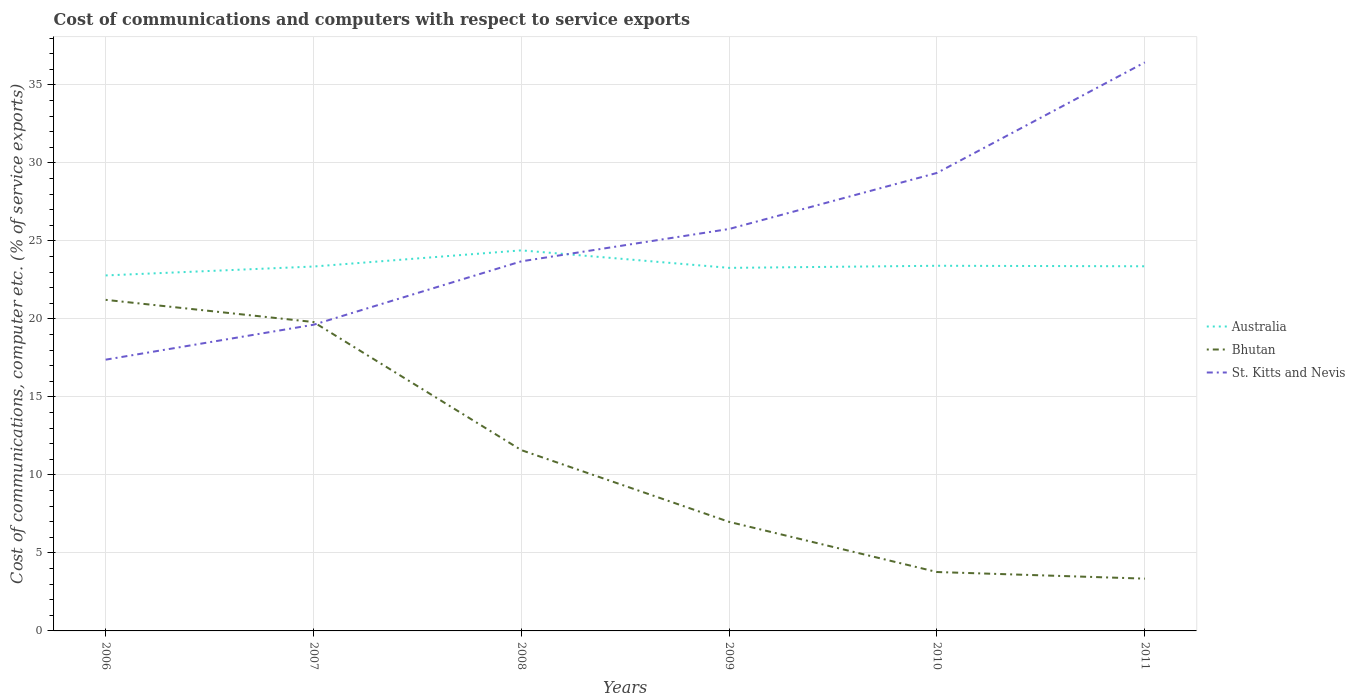Is the number of lines equal to the number of legend labels?
Your answer should be compact. Yes. Across all years, what is the maximum cost of communications and computers in Australia?
Your response must be concise. 22.79. What is the total cost of communications and computers in Australia in the graph?
Keep it short and to the point. -0.13. What is the difference between the highest and the second highest cost of communications and computers in St. Kitts and Nevis?
Offer a terse response. 19.05. How many lines are there?
Offer a very short reply. 3. What is the difference between two consecutive major ticks on the Y-axis?
Ensure brevity in your answer.  5. Does the graph contain any zero values?
Your answer should be compact. No. Does the graph contain grids?
Offer a very short reply. Yes. How many legend labels are there?
Provide a succinct answer. 3. How are the legend labels stacked?
Keep it short and to the point. Vertical. What is the title of the graph?
Provide a succinct answer. Cost of communications and computers with respect to service exports. Does "Least developed countries" appear as one of the legend labels in the graph?
Offer a very short reply. No. What is the label or title of the X-axis?
Provide a short and direct response. Years. What is the label or title of the Y-axis?
Keep it short and to the point. Cost of communications, computer etc. (% of service exports). What is the Cost of communications, computer etc. (% of service exports) of Australia in 2006?
Make the answer very short. 22.79. What is the Cost of communications, computer etc. (% of service exports) in Bhutan in 2006?
Ensure brevity in your answer.  21.22. What is the Cost of communications, computer etc. (% of service exports) in St. Kitts and Nevis in 2006?
Give a very brief answer. 17.39. What is the Cost of communications, computer etc. (% of service exports) of Australia in 2007?
Provide a succinct answer. 23.36. What is the Cost of communications, computer etc. (% of service exports) of Bhutan in 2007?
Your answer should be compact. 19.8. What is the Cost of communications, computer etc. (% of service exports) in St. Kitts and Nevis in 2007?
Your answer should be compact. 19.62. What is the Cost of communications, computer etc. (% of service exports) of Australia in 2008?
Keep it short and to the point. 24.39. What is the Cost of communications, computer etc. (% of service exports) of Bhutan in 2008?
Give a very brief answer. 11.59. What is the Cost of communications, computer etc. (% of service exports) in St. Kitts and Nevis in 2008?
Your answer should be very brief. 23.69. What is the Cost of communications, computer etc. (% of service exports) of Australia in 2009?
Ensure brevity in your answer.  23.27. What is the Cost of communications, computer etc. (% of service exports) in Bhutan in 2009?
Your answer should be compact. 6.99. What is the Cost of communications, computer etc. (% of service exports) in St. Kitts and Nevis in 2009?
Your answer should be very brief. 25.76. What is the Cost of communications, computer etc. (% of service exports) of Australia in 2010?
Keep it short and to the point. 23.41. What is the Cost of communications, computer etc. (% of service exports) of Bhutan in 2010?
Your answer should be very brief. 3.78. What is the Cost of communications, computer etc. (% of service exports) of St. Kitts and Nevis in 2010?
Offer a terse response. 29.36. What is the Cost of communications, computer etc. (% of service exports) of Australia in 2011?
Your response must be concise. 23.37. What is the Cost of communications, computer etc. (% of service exports) in Bhutan in 2011?
Offer a very short reply. 3.35. What is the Cost of communications, computer etc. (% of service exports) of St. Kitts and Nevis in 2011?
Give a very brief answer. 36.44. Across all years, what is the maximum Cost of communications, computer etc. (% of service exports) in Australia?
Ensure brevity in your answer.  24.39. Across all years, what is the maximum Cost of communications, computer etc. (% of service exports) in Bhutan?
Give a very brief answer. 21.22. Across all years, what is the maximum Cost of communications, computer etc. (% of service exports) in St. Kitts and Nevis?
Give a very brief answer. 36.44. Across all years, what is the minimum Cost of communications, computer etc. (% of service exports) in Australia?
Your answer should be very brief. 22.79. Across all years, what is the minimum Cost of communications, computer etc. (% of service exports) in Bhutan?
Keep it short and to the point. 3.35. Across all years, what is the minimum Cost of communications, computer etc. (% of service exports) in St. Kitts and Nevis?
Give a very brief answer. 17.39. What is the total Cost of communications, computer etc. (% of service exports) of Australia in the graph?
Your answer should be very brief. 140.58. What is the total Cost of communications, computer etc. (% of service exports) in Bhutan in the graph?
Your answer should be very brief. 66.72. What is the total Cost of communications, computer etc. (% of service exports) in St. Kitts and Nevis in the graph?
Keep it short and to the point. 152.26. What is the difference between the Cost of communications, computer etc. (% of service exports) in Australia in 2006 and that in 2007?
Keep it short and to the point. -0.57. What is the difference between the Cost of communications, computer etc. (% of service exports) of Bhutan in 2006 and that in 2007?
Your answer should be compact. 1.42. What is the difference between the Cost of communications, computer etc. (% of service exports) in St. Kitts and Nevis in 2006 and that in 2007?
Offer a terse response. -2.24. What is the difference between the Cost of communications, computer etc. (% of service exports) of Australia in 2006 and that in 2008?
Provide a short and direct response. -1.61. What is the difference between the Cost of communications, computer etc. (% of service exports) of Bhutan in 2006 and that in 2008?
Your answer should be very brief. 9.63. What is the difference between the Cost of communications, computer etc. (% of service exports) in St. Kitts and Nevis in 2006 and that in 2008?
Provide a short and direct response. -6.3. What is the difference between the Cost of communications, computer etc. (% of service exports) in Australia in 2006 and that in 2009?
Make the answer very short. -0.48. What is the difference between the Cost of communications, computer etc. (% of service exports) in Bhutan in 2006 and that in 2009?
Your answer should be very brief. 14.23. What is the difference between the Cost of communications, computer etc. (% of service exports) in St. Kitts and Nevis in 2006 and that in 2009?
Offer a terse response. -8.38. What is the difference between the Cost of communications, computer etc. (% of service exports) in Australia in 2006 and that in 2010?
Make the answer very short. -0.62. What is the difference between the Cost of communications, computer etc. (% of service exports) in Bhutan in 2006 and that in 2010?
Offer a very short reply. 17.45. What is the difference between the Cost of communications, computer etc. (% of service exports) in St. Kitts and Nevis in 2006 and that in 2010?
Make the answer very short. -11.97. What is the difference between the Cost of communications, computer etc. (% of service exports) in Australia in 2006 and that in 2011?
Provide a short and direct response. -0.59. What is the difference between the Cost of communications, computer etc. (% of service exports) in Bhutan in 2006 and that in 2011?
Offer a terse response. 17.87. What is the difference between the Cost of communications, computer etc. (% of service exports) of St. Kitts and Nevis in 2006 and that in 2011?
Offer a very short reply. -19.05. What is the difference between the Cost of communications, computer etc. (% of service exports) in Australia in 2007 and that in 2008?
Ensure brevity in your answer.  -1.04. What is the difference between the Cost of communications, computer etc. (% of service exports) of Bhutan in 2007 and that in 2008?
Ensure brevity in your answer.  8.21. What is the difference between the Cost of communications, computer etc. (% of service exports) in St. Kitts and Nevis in 2007 and that in 2008?
Give a very brief answer. -4.06. What is the difference between the Cost of communications, computer etc. (% of service exports) of Australia in 2007 and that in 2009?
Offer a very short reply. 0.09. What is the difference between the Cost of communications, computer etc. (% of service exports) in Bhutan in 2007 and that in 2009?
Your response must be concise. 12.81. What is the difference between the Cost of communications, computer etc. (% of service exports) in St. Kitts and Nevis in 2007 and that in 2009?
Keep it short and to the point. -6.14. What is the difference between the Cost of communications, computer etc. (% of service exports) in Australia in 2007 and that in 2010?
Your answer should be compact. -0.05. What is the difference between the Cost of communications, computer etc. (% of service exports) in Bhutan in 2007 and that in 2010?
Give a very brief answer. 16.02. What is the difference between the Cost of communications, computer etc. (% of service exports) of St. Kitts and Nevis in 2007 and that in 2010?
Offer a very short reply. -9.73. What is the difference between the Cost of communications, computer etc. (% of service exports) of Australia in 2007 and that in 2011?
Your answer should be very brief. -0.02. What is the difference between the Cost of communications, computer etc. (% of service exports) in Bhutan in 2007 and that in 2011?
Offer a very short reply. 16.45. What is the difference between the Cost of communications, computer etc. (% of service exports) of St. Kitts and Nevis in 2007 and that in 2011?
Your response must be concise. -16.82. What is the difference between the Cost of communications, computer etc. (% of service exports) of Australia in 2008 and that in 2009?
Make the answer very short. 1.12. What is the difference between the Cost of communications, computer etc. (% of service exports) of Bhutan in 2008 and that in 2009?
Your answer should be compact. 4.6. What is the difference between the Cost of communications, computer etc. (% of service exports) of St. Kitts and Nevis in 2008 and that in 2009?
Provide a short and direct response. -2.07. What is the difference between the Cost of communications, computer etc. (% of service exports) of Australia in 2008 and that in 2010?
Your answer should be very brief. 0.99. What is the difference between the Cost of communications, computer etc. (% of service exports) in Bhutan in 2008 and that in 2010?
Provide a short and direct response. 7.81. What is the difference between the Cost of communications, computer etc. (% of service exports) of St. Kitts and Nevis in 2008 and that in 2010?
Ensure brevity in your answer.  -5.67. What is the difference between the Cost of communications, computer etc. (% of service exports) of Australia in 2008 and that in 2011?
Offer a very short reply. 1.02. What is the difference between the Cost of communications, computer etc. (% of service exports) in Bhutan in 2008 and that in 2011?
Offer a terse response. 8.24. What is the difference between the Cost of communications, computer etc. (% of service exports) in St. Kitts and Nevis in 2008 and that in 2011?
Keep it short and to the point. -12.75. What is the difference between the Cost of communications, computer etc. (% of service exports) in Australia in 2009 and that in 2010?
Provide a short and direct response. -0.13. What is the difference between the Cost of communications, computer etc. (% of service exports) in Bhutan in 2009 and that in 2010?
Give a very brief answer. 3.21. What is the difference between the Cost of communications, computer etc. (% of service exports) of St. Kitts and Nevis in 2009 and that in 2010?
Your answer should be compact. -3.59. What is the difference between the Cost of communications, computer etc. (% of service exports) in Australia in 2009 and that in 2011?
Provide a short and direct response. -0.1. What is the difference between the Cost of communications, computer etc. (% of service exports) in Bhutan in 2009 and that in 2011?
Offer a very short reply. 3.64. What is the difference between the Cost of communications, computer etc. (% of service exports) in St. Kitts and Nevis in 2009 and that in 2011?
Offer a terse response. -10.68. What is the difference between the Cost of communications, computer etc. (% of service exports) in Australia in 2010 and that in 2011?
Your answer should be very brief. 0.03. What is the difference between the Cost of communications, computer etc. (% of service exports) in Bhutan in 2010 and that in 2011?
Your answer should be compact. 0.42. What is the difference between the Cost of communications, computer etc. (% of service exports) in St. Kitts and Nevis in 2010 and that in 2011?
Your answer should be compact. -7.08. What is the difference between the Cost of communications, computer etc. (% of service exports) of Australia in 2006 and the Cost of communications, computer etc. (% of service exports) of Bhutan in 2007?
Your answer should be very brief. 2.99. What is the difference between the Cost of communications, computer etc. (% of service exports) in Australia in 2006 and the Cost of communications, computer etc. (% of service exports) in St. Kitts and Nevis in 2007?
Your response must be concise. 3.16. What is the difference between the Cost of communications, computer etc. (% of service exports) of Bhutan in 2006 and the Cost of communications, computer etc. (% of service exports) of St. Kitts and Nevis in 2007?
Make the answer very short. 1.6. What is the difference between the Cost of communications, computer etc. (% of service exports) of Australia in 2006 and the Cost of communications, computer etc. (% of service exports) of Bhutan in 2008?
Offer a terse response. 11.2. What is the difference between the Cost of communications, computer etc. (% of service exports) in Australia in 2006 and the Cost of communications, computer etc. (% of service exports) in St. Kitts and Nevis in 2008?
Provide a succinct answer. -0.9. What is the difference between the Cost of communications, computer etc. (% of service exports) in Bhutan in 2006 and the Cost of communications, computer etc. (% of service exports) in St. Kitts and Nevis in 2008?
Make the answer very short. -2.47. What is the difference between the Cost of communications, computer etc. (% of service exports) in Australia in 2006 and the Cost of communications, computer etc. (% of service exports) in Bhutan in 2009?
Provide a succinct answer. 15.8. What is the difference between the Cost of communications, computer etc. (% of service exports) of Australia in 2006 and the Cost of communications, computer etc. (% of service exports) of St. Kitts and Nevis in 2009?
Your answer should be compact. -2.98. What is the difference between the Cost of communications, computer etc. (% of service exports) in Bhutan in 2006 and the Cost of communications, computer etc. (% of service exports) in St. Kitts and Nevis in 2009?
Provide a short and direct response. -4.54. What is the difference between the Cost of communications, computer etc. (% of service exports) of Australia in 2006 and the Cost of communications, computer etc. (% of service exports) of Bhutan in 2010?
Keep it short and to the point. 19.01. What is the difference between the Cost of communications, computer etc. (% of service exports) in Australia in 2006 and the Cost of communications, computer etc. (% of service exports) in St. Kitts and Nevis in 2010?
Offer a very short reply. -6.57. What is the difference between the Cost of communications, computer etc. (% of service exports) of Bhutan in 2006 and the Cost of communications, computer etc. (% of service exports) of St. Kitts and Nevis in 2010?
Keep it short and to the point. -8.14. What is the difference between the Cost of communications, computer etc. (% of service exports) of Australia in 2006 and the Cost of communications, computer etc. (% of service exports) of Bhutan in 2011?
Keep it short and to the point. 19.43. What is the difference between the Cost of communications, computer etc. (% of service exports) in Australia in 2006 and the Cost of communications, computer etc. (% of service exports) in St. Kitts and Nevis in 2011?
Ensure brevity in your answer.  -13.66. What is the difference between the Cost of communications, computer etc. (% of service exports) in Bhutan in 2006 and the Cost of communications, computer etc. (% of service exports) in St. Kitts and Nevis in 2011?
Your answer should be compact. -15.22. What is the difference between the Cost of communications, computer etc. (% of service exports) in Australia in 2007 and the Cost of communications, computer etc. (% of service exports) in Bhutan in 2008?
Ensure brevity in your answer.  11.77. What is the difference between the Cost of communications, computer etc. (% of service exports) of Australia in 2007 and the Cost of communications, computer etc. (% of service exports) of St. Kitts and Nevis in 2008?
Offer a very short reply. -0.33. What is the difference between the Cost of communications, computer etc. (% of service exports) of Bhutan in 2007 and the Cost of communications, computer etc. (% of service exports) of St. Kitts and Nevis in 2008?
Give a very brief answer. -3.89. What is the difference between the Cost of communications, computer etc. (% of service exports) of Australia in 2007 and the Cost of communications, computer etc. (% of service exports) of Bhutan in 2009?
Make the answer very short. 16.37. What is the difference between the Cost of communications, computer etc. (% of service exports) in Australia in 2007 and the Cost of communications, computer etc. (% of service exports) in St. Kitts and Nevis in 2009?
Offer a terse response. -2.41. What is the difference between the Cost of communications, computer etc. (% of service exports) of Bhutan in 2007 and the Cost of communications, computer etc. (% of service exports) of St. Kitts and Nevis in 2009?
Your answer should be compact. -5.96. What is the difference between the Cost of communications, computer etc. (% of service exports) of Australia in 2007 and the Cost of communications, computer etc. (% of service exports) of Bhutan in 2010?
Offer a very short reply. 19.58. What is the difference between the Cost of communications, computer etc. (% of service exports) of Australia in 2007 and the Cost of communications, computer etc. (% of service exports) of St. Kitts and Nevis in 2010?
Keep it short and to the point. -6. What is the difference between the Cost of communications, computer etc. (% of service exports) in Bhutan in 2007 and the Cost of communications, computer etc. (% of service exports) in St. Kitts and Nevis in 2010?
Your answer should be compact. -9.56. What is the difference between the Cost of communications, computer etc. (% of service exports) of Australia in 2007 and the Cost of communications, computer etc. (% of service exports) of Bhutan in 2011?
Make the answer very short. 20.01. What is the difference between the Cost of communications, computer etc. (% of service exports) in Australia in 2007 and the Cost of communications, computer etc. (% of service exports) in St. Kitts and Nevis in 2011?
Offer a very short reply. -13.08. What is the difference between the Cost of communications, computer etc. (% of service exports) in Bhutan in 2007 and the Cost of communications, computer etc. (% of service exports) in St. Kitts and Nevis in 2011?
Offer a very short reply. -16.64. What is the difference between the Cost of communications, computer etc. (% of service exports) of Australia in 2008 and the Cost of communications, computer etc. (% of service exports) of Bhutan in 2009?
Make the answer very short. 17.4. What is the difference between the Cost of communications, computer etc. (% of service exports) of Australia in 2008 and the Cost of communications, computer etc. (% of service exports) of St. Kitts and Nevis in 2009?
Offer a terse response. -1.37. What is the difference between the Cost of communications, computer etc. (% of service exports) in Bhutan in 2008 and the Cost of communications, computer etc. (% of service exports) in St. Kitts and Nevis in 2009?
Offer a very short reply. -14.17. What is the difference between the Cost of communications, computer etc. (% of service exports) in Australia in 2008 and the Cost of communications, computer etc. (% of service exports) in Bhutan in 2010?
Provide a succinct answer. 20.62. What is the difference between the Cost of communications, computer etc. (% of service exports) of Australia in 2008 and the Cost of communications, computer etc. (% of service exports) of St. Kitts and Nevis in 2010?
Offer a terse response. -4.96. What is the difference between the Cost of communications, computer etc. (% of service exports) in Bhutan in 2008 and the Cost of communications, computer etc. (% of service exports) in St. Kitts and Nevis in 2010?
Ensure brevity in your answer.  -17.77. What is the difference between the Cost of communications, computer etc. (% of service exports) of Australia in 2008 and the Cost of communications, computer etc. (% of service exports) of Bhutan in 2011?
Offer a terse response. 21.04. What is the difference between the Cost of communications, computer etc. (% of service exports) in Australia in 2008 and the Cost of communications, computer etc. (% of service exports) in St. Kitts and Nevis in 2011?
Give a very brief answer. -12.05. What is the difference between the Cost of communications, computer etc. (% of service exports) of Bhutan in 2008 and the Cost of communications, computer etc. (% of service exports) of St. Kitts and Nevis in 2011?
Provide a succinct answer. -24.85. What is the difference between the Cost of communications, computer etc. (% of service exports) in Australia in 2009 and the Cost of communications, computer etc. (% of service exports) in Bhutan in 2010?
Offer a very short reply. 19.5. What is the difference between the Cost of communications, computer etc. (% of service exports) of Australia in 2009 and the Cost of communications, computer etc. (% of service exports) of St. Kitts and Nevis in 2010?
Your answer should be very brief. -6.09. What is the difference between the Cost of communications, computer etc. (% of service exports) in Bhutan in 2009 and the Cost of communications, computer etc. (% of service exports) in St. Kitts and Nevis in 2010?
Make the answer very short. -22.37. What is the difference between the Cost of communications, computer etc. (% of service exports) in Australia in 2009 and the Cost of communications, computer etc. (% of service exports) in Bhutan in 2011?
Provide a short and direct response. 19.92. What is the difference between the Cost of communications, computer etc. (% of service exports) of Australia in 2009 and the Cost of communications, computer etc. (% of service exports) of St. Kitts and Nevis in 2011?
Provide a short and direct response. -13.17. What is the difference between the Cost of communications, computer etc. (% of service exports) in Bhutan in 2009 and the Cost of communications, computer etc. (% of service exports) in St. Kitts and Nevis in 2011?
Give a very brief answer. -29.45. What is the difference between the Cost of communications, computer etc. (% of service exports) of Australia in 2010 and the Cost of communications, computer etc. (% of service exports) of Bhutan in 2011?
Give a very brief answer. 20.05. What is the difference between the Cost of communications, computer etc. (% of service exports) of Australia in 2010 and the Cost of communications, computer etc. (% of service exports) of St. Kitts and Nevis in 2011?
Your answer should be very brief. -13.04. What is the difference between the Cost of communications, computer etc. (% of service exports) of Bhutan in 2010 and the Cost of communications, computer etc. (% of service exports) of St. Kitts and Nevis in 2011?
Your answer should be very brief. -32.67. What is the average Cost of communications, computer etc. (% of service exports) in Australia per year?
Offer a terse response. 23.43. What is the average Cost of communications, computer etc. (% of service exports) in Bhutan per year?
Your answer should be compact. 11.12. What is the average Cost of communications, computer etc. (% of service exports) of St. Kitts and Nevis per year?
Your answer should be very brief. 25.38. In the year 2006, what is the difference between the Cost of communications, computer etc. (% of service exports) in Australia and Cost of communications, computer etc. (% of service exports) in Bhutan?
Your response must be concise. 1.56. In the year 2006, what is the difference between the Cost of communications, computer etc. (% of service exports) of Australia and Cost of communications, computer etc. (% of service exports) of St. Kitts and Nevis?
Your answer should be compact. 5.4. In the year 2006, what is the difference between the Cost of communications, computer etc. (% of service exports) of Bhutan and Cost of communications, computer etc. (% of service exports) of St. Kitts and Nevis?
Provide a succinct answer. 3.83. In the year 2007, what is the difference between the Cost of communications, computer etc. (% of service exports) of Australia and Cost of communications, computer etc. (% of service exports) of Bhutan?
Your answer should be very brief. 3.56. In the year 2007, what is the difference between the Cost of communications, computer etc. (% of service exports) of Australia and Cost of communications, computer etc. (% of service exports) of St. Kitts and Nevis?
Your answer should be compact. 3.73. In the year 2007, what is the difference between the Cost of communications, computer etc. (% of service exports) of Bhutan and Cost of communications, computer etc. (% of service exports) of St. Kitts and Nevis?
Provide a succinct answer. 0.17. In the year 2008, what is the difference between the Cost of communications, computer etc. (% of service exports) in Australia and Cost of communications, computer etc. (% of service exports) in Bhutan?
Offer a very short reply. 12.8. In the year 2008, what is the difference between the Cost of communications, computer etc. (% of service exports) of Australia and Cost of communications, computer etc. (% of service exports) of St. Kitts and Nevis?
Keep it short and to the point. 0.7. In the year 2008, what is the difference between the Cost of communications, computer etc. (% of service exports) in Bhutan and Cost of communications, computer etc. (% of service exports) in St. Kitts and Nevis?
Your response must be concise. -12.1. In the year 2009, what is the difference between the Cost of communications, computer etc. (% of service exports) in Australia and Cost of communications, computer etc. (% of service exports) in Bhutan?
Ensure brevity in your answer.  16.28. In the year 2009, what is the difference between the Cost of communications, computer etc. (% of service exports) in Australia and Cost of communications, computer etc. (% of service exports) in St. Kitts and Nevis?
Your response must be concise. -2.49. In the year 2009, what is the difference between the Cost of communications, computer etc. (% of service exports) in Bhutan and Cost of communications, computer etc. (% of service exports) in St. Kitts and Nevis?
Offer a terse response. -18.77. In the year 2010, what is the difference between the Cost of communications, computer etc. (% of service exports) in Australia and Cost of communications, computer etc. (% of service exports) in Bhutan?
Ensure brevity in your answer.  19.63. In the year 2010, what is the difference between the Cost of communications, computer etc. (% of service exports) of Australia and Cost of communications, computer etc. (% of service exports) of St. Kitts and Nevis?
Ensure brevity in your answer.  -5.95. In the year 2010, what is the difference between the Cost of communications, computer etc. (% of service exports) in Bhutan and Cost of communications, computer etc. (% of service exports) in St. Kitts and Nevis?
Your answer should be very brief. -25.58. In the year 2011, what is the difference between the Cost of communications, computer etc. (% of service exports) of Australia and Cost of communications, computer etc. (% of service exports) of Bhutan?
Give a very brief answer. 20.02. In the year 2011, what is the difference between the Cost of communications, computer etc. (% of service exports) of Australia and Cost of communications, computer etc. (% of service exports) of St. Kitts and Nevis?
Give a very brief answer. -13.07. In the year 2011, what is the difference between the Cost of communications, computer etc. (% of service exports) of Bhutan and Cost of communications, computer etc. (% of service exports) of St. Kitts and Nevis?
Your answer should be compact. -33.09. What is the ratio of the Cost of communications, computer etc. (% of service exports) of Australia in 2006 to that in 2007?
Ensure brevity in your answer.  0.98. What is the ratio of the Cost of communications, computer etc. (% of service exports) in Bhutan in 2006 to that in 2007?
Offer a very short reply. 1.07. What is the ratio of the Cost of communications, computer etc. (% of service exports) in St. Kitts and Nevis in 2006 to that in 2007?
Your response must be concise. 0.89. What is the ratio of the Cost of communications, computer etc. (% of service exports) in Australia in 2006 to that in 2008?
Provide a succinct answer. 0.93. What is the ratio of the Cost of communications, computer etc. (% of service exports) in Bhutan in 2006 to that in 2008?
Make the answer very short. 1.83. What is the ratio of the Cost of communications, computer etc. (% of service exports) in St. Kitts and Nevis in 2006 to that in 2008?
Your response must be concise. 0.73. What is the ratio of the Cost of communications, computer etc. (% of service exports) of Australia in 2006 to that in 2009?
Your response must be concise. 0.98. What is the ratio of the Cost of communications, computer etc. (% of service exports) of Bhutan in 2006 to that in 2009?
Your answer should be compact. 3.04. What is the ratio of the Cost of communications, computer etc. (% of service exports) of St. Kitts and Nevis in 2006 to that in 2009?
Make the answer very short. 0.67. What is the ratio of the Cost of communications, computer etc. (% of service exports) of Australia in 2006 to that in 2010?
Your answer should be very brief. 0.97. What is the ratio of the Cost of communications, computer etc. (% of service exports) in Bhutan in 2006 to that in 2010?
Your answer should be very brief. 5.62. What is the ratio of the Cost of communications, computer etc. (% of service exports) of St. Kitts and Nevis in 2006 to that in 2010?
Your answer should be very brief. 0.59. What is the ratio of the Cost of communications, computer etc. (% of service exports) of Australia in 2006 to that in 2011?
Offer a terse response. 0.97. What is the ratio of the Cost of communications, computer etc. (% of service exports) in Bhutan in 2006 to that in 2011?
Provide a short and direct response. 6.33. What is the ratio of the Cost of communications, computer etc. (% of service exports) of St. Kitts and Nevis in 2006 to that in 2011?
Offer a very short reply. 0.48. What is the ratio of the Cost of communications, computer etc. (% of service exports) of Australia in 2007 to that in 2008?
Your response must be concise. 0.96. What is the ratio of the Cost of communications, computer etc. (% of service exports) of Bhutan in 2007 to that in 2008?
Make the answer very short. 1.71. What is the ratio of the Cost of communications, computer etc. (% of service exports) of St. Kitts and Nevis in 2007 to that in 2008?
Offer a very short reply. 0.83. What is the ratio of the Cost of communications, computer etc. (% of service exports) of Bhutan in 2007 to that in 2009?
Your response must be concise. 2.83. What is the ratio of the Cost of communications, computer etc. (% of service exports) of St. Kitts and Nevis in 2007 to that in 2009?
Your answer should be compact. 0.76. What is the ratio of the Cost of communications, computer etc. (% of service exports) of Australia in 2007 to that in 2010?
Ensure brevity in your answer.  1. What is the ratio of the Cost of communications, computer etc. (% of service exports) of Bhutan in 2007 to that in 2010?
Ensure brevity in your answer.  5.24. What is the ratio of the Cost of communications, computer etc. (% of service exports) in St. Kitts and Nevis in 2007 to that in 2010?
Provide a succinct answer. 0.67. What is the ratio of the Cost of communications, computer etc. (% of service exports) in Bhutan in 2007 to that in 2011?
Your answer should be compact. 5.91. What is the ratio of the Cost of communications, computer etc. (% of service exports) in St. Kitts and Nevis in 2007 to that in 2011?
Provide a succinct answer. 0.54. What is the ratio of the Cost of communications, computer etc. (% of service exports) of Australia in 2008 to that in 2009?
Make the answer very short. 1.05. What is the ratio of the Cost of communications, computer etc. (% of service exports) of Bhutan in 2008 to that in 2009?
Ensure brevity in your answer.  1.66. What is the ratio of the Cost of communications, computer etc. (% of service exports) of St. Kitts and Nevis in 2008 to that in 2009?
Ensure brevity in your answer.  0.92. What is the ratio of the Cost of communications, computer etc. (% of service exports) in Australia in 2008 to that in 2010?
Make the answer very short. 1.04. What is the ratio of the Cost of communications, computer etc. (% of service exports) in Bhutan in 2008 to that in 2010?
Keep it short and to the point. 3.07. What is the ratio of the Cost of communications, computer etc. (% of service exports) in St. Kitts and Nevis in 2008 to that in 2010?
Offer a terse response. 0.81. What is the ratio of the Cost of communications, computer etc. (% of service exports) of Australia in 2008 to that in 2011?
Offer a terse response. 1.04. What is the ratio of the Cost of communications, computer etc. (% of service exports) in Bhutan in 2008 to that in 2011?
Provide a succinct answer. 3.46. What is the ratio of the Cost of communications, computer etc. (% of service exports) in St. Kitts and Nevis in 2008 to that in 2011?
Keep it short and to the point. 0.65. What is the ratio of the Cost of communications, computer etc. (% of service exports) of Bhutan in 2009 to that in 2010?
Your answer should be compact. 1.85. What is the ratio of the Cost of communications, computer etc. (% of service exports) of St. Kitts and Nevis in 2009 to that in 2010?
Keep it short and to the point. 0.88. What is the ratio of the Cost of communications, computer etc. (% of service exports) of Australia in 2009 to that in 2011?
Give a very brief answer. 1. What is the ratio of the Cost of communications, computer etc. (% of service exports) in Bhutan in 2009 to that in 2011?
Your response must be concise. 2.09. What is the ratio of the Cost of communications, computer etc. (% of service exports) in St. Kitts and Nevis in 2009 to that in 2011?
Ensure brevity in your answer.  0.71. What is the ratio of the Cost of communications, computer etc. (% of service exports) in Australia in 2010 to that in 2011?
Provide a succinct answer. 1. What is the ratio of the Cost of communications, computer etc. (% of service exports) of Bhutan in 2010 to that in 2011?
Keep it short and to the point. 1.13. What is the ratio of the Cost of communications, computer etc. (% of service exports) in St. Kitts and Nevis in 2010 to that in 2011?
Keep it short and to the point. 0.81. What is the difference between the highest and the second highest Cost of communications, computer etc. (% of service exports) of Australia?
Offer a very short reply. 0.99. What is the difference between the highest and the second highest Cost of communications, computer etc. (% of service exports) in Bhutan?
Ensure brevity in your answer.  1.42. What is the difference between the highest and the second highest Cost of communications, computer etc. (% of service exports) of St. Kitts and Nevis?
Keep it short and to the point. 7.08. What is the difference between the highest and the lowest Cost of communications, computer etc. (% of service exports) in Australia?
Give a very brief answer. 1.61. What is the difference between the highest and the lowest Cost of communications, computer etc. (% of service exports) in Bhutan?
Keep it short and to the point. 17.87. What is the difference between the highest and the lowest Cost of communications, computer etc. (% of service exports) in St. Kitts and Nevis?
Make the answer very short. 19.05. 